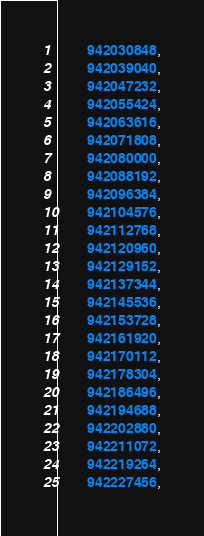<code> <loc_0><loc_0><loc_500><loc_500><_C++_>		942030848,
		942039040,
		942047232,
		942055424,
		942063616,
		942071808,
		942080000,
		942088192,
		942096384,
		942104576,
		942112768,
		942120960,
		942129152,
		942137344,
		942145536,
		942153728,
		942161920,
		942170112,
		942178304,
		942186496,
		942194688,
		942202880,
		942211072,
		942219264,
		942227456,</code> 